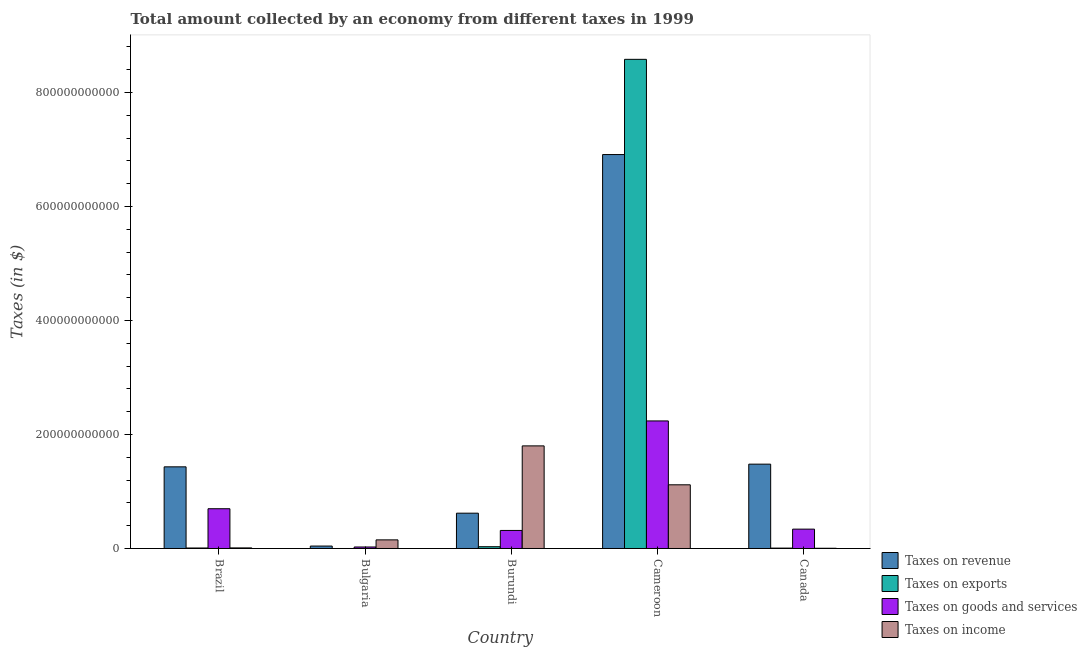How many groups of bars are there?
Your answer should be compact. 5. Are the number of bars on each tick of the X-axis equal?
Keep it short and to the point. No. How many bars are there on the 1st tick from the left?
Offer a very short reply. 4. How many bars are there on the 5th tick from the right?
Provide a short and direct response. 4. What is the label of the 5th group of bars from the left?
Ensure brevity in your answer.  Canada. In how many cases, is the number of bars for a given country not equal to the number of legend labels?
Keep it short and to the point. 1. What is the amount collected as tax on exports in Bulgaria?
Ensure brevity in your answer.  0. Across all countries, what is the maximum amount collected as tax on revenue?
Make the answer very short. 6.91e+11. Across all countries, what is the minimum amount collected as tax on goods?
Offer a terse response. 2.63e+09. In which country was the amount collected as tax on income maximum?
Give a very brief answer. Burundi. What is the total amount collected as tax on revenue in the graph?
Give a very brief answer. 1.05e+12. What is the difference between the amount collected as tax on income in Brazil and that in Burundi?
Keep it short and to the point. -1.79e+11. What is the difference between the amount collected as tax on exports in Bulgaria and the amount collected as tax on goods in Cameroon?
Offer a terse response. -2.24e+11. What is the average amount collected as tax on revenue per country?
Offer a very short reply. 2.10e+11. What is the difference between the amount collected as tax on revenue and amount collected as tax on exports in Cameroon?
Offer a very short reply. -1.67e+11. What is the ratio of the amount collected as tax on goods in Burundi to that in Cameroon?
Provide a succinct answer. 0.14. Is the amount collected as tax on exports in Burundi less than that in Canada?
Provide a succinct answer. No. Is the difference between the amount collected as tax on revenue in Brazil and Burundi greater than the difference between the amount collected as tax on exports in Brazil and Burundi?
Offer a very short reply. Yes. What is the difference between the highest and the second highest amount collected as tax on exports?
Provide a succinct answer. 8.55e+11. What is the difference between the highest and the lowest amount collected as tax on revenue?
Keep it short and to the point. 6.87e+11. Is it the case that in every country, the sum of the amount collected as tax on goods and amount collected as tax on revenue is greater than the sum of amount collected as tax on exports and amount collected as tax on income?
Offer a terse response. Yes. How many bars are there?
Make the answer very short. 19. Are all the bars in the graph horizontal?
Offer a very short reply. No. What is the difference between two consecutive major ticks on the Y-axis?
Offer a terse response. 2.00e+11. Does the graph contain grids?
Offer a very short reply. No. Where does the legend appear in the graph?
Your answer should be very brief. Bottom right. How many legend labels are there?
Ensure brevity in your answer.  4. How are the legend labels stacked?
Give a very brief answer. Vertical. What is the title of the graph?
Give a very brief answer. Total amount collected by an economy from different taxes in 1999. What is the label or title of the Y-axis?
Offer a very short reply. Taxes (in $). What is the Taxes (in $) of Taxes on revenue in Brazil?
Your response must be concise. 1.43e+11. What is the Taxes (in $) in Taxes on exports in Brazil?
Ensure brevity in your answer.  8.80e+08. What is the Taxes (in $) of Taxes on goods and services in Brazil?
Give a very brief answer. 6.97e+1. What is the Taxes (in $) of Taxes on income in Brazil?
Make the answer very short. 1.03e+09. What is the Taxes (in $) in Taxes on revenue in Bulgaria?
Your answer should be compact. 4.26e+09. What is the Taxes (in $) of Taxes on goods and services in Bulgaria?
Provide a succinct answer. 2.63e+09. What is the Taxes (in $) in Taxes on income in Bulgaria?
Provide a short and direct response. 1.51e+1. What is the Taxes (in $) in Taxes on revenue in Burundi?
Provide a short and direct response. 6.19e+1. What is the Taxes (in $) of Taxes on exports in Burundi?
Offer a terse response. 3.12e+09. What is the Taxes (in $) in Taxes on goods and services in Burundi?
Your answer should be very brief. 3.16e+1. What is the Taxes (in $) of Taxes on income in Burundi?
Keep it short and to the point. 1.80e+11. What is the Taxes (in $) in Taxes on revenue in Cameroon?
Ensure brevity in your answer.  6.91e+11. What is the Taxes (in $) in Taxes on exports in Cameroon?
Make the answer very short. 8.58e+11. What is the Taxes (in $) of Taxes on goods and services in Cameroon?
Provide a short and direct response. 2.24e+11. What is the Taxes (in $) of Taxes on income in Cameroon?
Ensure brevity in your answer.  1.12e+11. What is the Taxes (in $) in Taxes on revenue in Canada?
Your answer should be compact. 1.48e+11. What is the Taxes (in $) of Taxes on exports in Canada?
Keep it short and to the point. 6.70e+08. What is the Taxes (in $) in Taxes on goods and services in Canada?
Your response must be concise. 3.39e+1. What is the Taxes (in $) of Taxes on income in Canada?
Offer a very short reply. 4.08e+08. Across all countries, what is the maximum Taxes (in $) in Taxes on revenue?
Keep it short and to the point. 6.91e+11. Across all countries, what is the maximum Taxes (in $) of Taxes on exports?
Your response must be concise. 8.58e+11. Across all countries, what is the maximum Taxes (in $) of Taxes on goods and services?
Offer a terse response. 2.24e+11. Across all countries, what is the maximum Taxes (in $) in Taxes on income?
Provide a short and direct response. 1.80e+11. Across all countries, what is the minimum Taxes (in $) of Taxes on revenue?
Your response must be concise. 4.26e+09. Across all countries, what is the minimum Taxes (in $) of Taxes on goods and services?
Provide a succinct answer. 2.63e+09. Across all countries, what is the minimum Taxes (in $) in Taxes on income?
Your answer should be compact. 4.08e+08. What is the total Taxes (in $) in Taxes on revenue in the graph?
Your answer should be compact. 1.05e+12. What is the total Taxes (in $) of Taxes on exports in the graph?
Provide a short and direct response. 8.63e+11. What is the total Taxes (in $) of Taxes on goods and services in the graph?
Your response must be concise. 3.62e+11. What is the total Taxes (in $) in Taxes on income in the graph?
Provide a succinct answer. 3.08e+11. What is the difference between the Taxes (in $) of Taxes on revenue in Brazil and that in Bulgaria?
Your answer should be very brief. 1.39e+11. What is the difference between the Taxes (in $) in Taxes on goods and services in Brazil and that in Bulgaria?
Provide a short and direct response. 6.71e+1. What is the difference between the Taxes (in $) of Taxes on income in Brazil and that in Bulgaria?
Offer a very short reply. -1.41e+1. What is the difference between the Taxes (in $) in Taxes on revenue in Brazil and that in Burundi?
Provide a succinct answer. 8.13e+1. What is the difference between the Taxes (in $) of Taxes on exports in Brazil and that in Burundi?
Your answer should be compact. -2.24e+09. What is the difference between the Taxes (in $) in Taxes on goods and services in Brazil and that in Burundi?
Ensure brevity in your answer.  3.81e+1. What is the difference between the Taxes (in $) of Taxes on income in Brazil and that in Burundi?
Offer a terse response. -1.79e+11. What is the difference between the Taxes (in $) of Taxes on revenue in Brazil and that in Cameroon?
Provide a succinct answer. -5.48e+11. What is the difference between the Taxes (in $) in Taxes on exports in Brazil and that in Cameroon?
Your response must be concise. -8.57e+11. What is the difference between the Taxes (in $) in Taxes on goods and services in Brazil and that in Cameroon?
Your answer should be very brief. -1.54e+11. What is the difference between the Taxes (in $) in Taxes on income in Brazil and that in Cameroon?
Provide a succinct answer. -1.11e+11. What is the difference between the Taxes (in $) of Taxes on revenue in Brazil and that in Canada?
Ensure brevity in your answer.  -4.71e+09. What is the difference between the Taxes (in $) in Taxes on exports in Brazil and that in Canada?
Provide a succinct answer. 2.10e+08. What is the difference between the Taxes (in $) of Taxes on goods and services in Brazil and that in Canada?
Keep it short and to the point. 3.58e+1. What is the difference between the Taxes (in $) in Taxes on income in Brazil and that in Canada?
Make the answer very short. 6.21e+08. What is the difference between the Taxes (in $) in Taxes on revenue in Bulgaria and that in Burundi?
Give a very brief answer. -5.77e+1. What is the difference between the Taxes (in $) of Taxes on goods and services in Bulgaria and that in Burundi?
Offer a terse response. -2.90e+1. What is the difference between the Taxes (in $) in Taxes on income in Bulgaria and that in Burundi?
Offer a terse response. -1.65e+11. What is the difference between the Taxes (in $) of Taxes on revenue in Bulgaria and that in Cameroon?
Make the answer very short. -6.87e+11. What is the difference between the Taxes (in $) in Taxes on goods and services in Bulgaria and that in Cameroon?
Your answer should be compact. -2.21e+11. What is the difference between the Taxes (in $) in Taxes on income in Bulgaria and that in Cameroon?
Provide a short and direct response. -9.66e+1. What is the difference between the Taxes (in $) in Taxes on revenue in Bulgaria and that in Canada?
Your answer should be very brief. -1.44e+11. What is the difference between the Taxes (in $) in Taxes on goods and services in Bulgaria and that in Canada?
Offer a terse response. -3.13e+1. What is the difference between the Taxes (in $) in Taxes on income in Bulgaria and that in Canada?
Make the answer very short. 1.47e+1. What is the difference between the Taxes (in $) in Taxes on revenue in Burundi and that in Cameroon?
Ensure brevity in your answer.  -6.29e+11. What is the difference between the Taxes (in $) of Taxes on exports in Burundi and that in Cameroon?
Your answer should be compact. -8.55e+11. What is the difference between the Taxes (in $) in Taxes on goods and services in Burundi and that in Cameroon?
Keep it short and to the point. -1.92e+11. What is the difference between the Taxes (in $) of Taxes on income in Burundi and that in Cameroon?
Offer a terse response. 6.83e+1. What is the difference between the Taxes (in $) in Taxes on revenue in Burundi and that in Canada?
Give a very brief answer. -8.60e+1. What is the difference between the Taxes (in $) of Taxes on exports in Burundi and that in Canada?
Provide a succinct answer. 2.45e+09. What is the difference between the Taxes (in $) in Taxes on goods and services in Burundi and that in Canada?
Give a very brief answer. -2.31e+09. What is the difference between the Taxes (in $) in Taxes on income in Burundi and that in Canada?
Give a very brief answer. 1.80e+11. What is the difference between the Taxes (in $) in Taxes on revenue in Cameroon and that in Canada?
Your answer should be very brief. 5.43e+11. What is the difference between the Taxes (in $) of Taxes on exports in Cameroon and that in Canada?
Make the answer very short. 8.57e+11. What is the difference between the Taxes (in $) in Taxes on goods and services in Cameroon and that in Canada?
Your response must be concise. 1.90e+11. What is the difference between the Taxes (in $) in Taxes on income in Cameroon and that in Canada?
Keep it short and to the point. 1.11e+11. What is the difference between the Taxes (in $) in Taxes on revenue in Brazil and the Taxes (in $) in Taxes on goods and services in Bulgaria?
Keep it short and to the point. 1.41e+11. What is the difference between the Taxes (in $) of Taxes on revenue in Brazil and the Taxes (in $) of Taxes on income in Bulgaria?
Give a very brief answer. 1.28e+11. What is the difference between the Taxes (in $) in Taxes on exports in Brazil and the Taxes (in $) in Taxes on goods and services in Bulgaria?
Your response must be concise. -1.75e+09. What is the difference between the Taxes (in $) of Taxes on exports in Brazil and the Taxes (in $) of Taxes on income in Bulgaria?
Make the answer very short. -1.42e+1. What is the difference between the Taxes (in $) in Taxes on goods and services in Brazil and the Taxes (in $) in Taxes on income in Bulgaria?
Your response must be concise. 5.46e+1. What is the difference between the Taxes (in $) in Taxes on revenue in Brazil and the Taxes (in $) in Taxes on exports in Burundi?
Your answer should be very brief. 1.40e+11. What is the difference between the Taxes (in $) in Taxes on revenue in Brazil and the Taxes (in $) in Taxes on goods and services in Burundi?
Give a very brief answer. 1.12e+11. What is the difference between the Taxes (in $) of Taxes on revenue in Brazil and the Taxes (in $) of Taxes on income in Burundi?
Your answer should be compact. -3.68e+1. What is the difference between the Taxes (in $) in Taxes on exports in Brazil and the Taxes (in $) in Taxes on goods and services in Burundi?
Ensure brevity in your answer.  -3.08e+1. What is the difference between the Taxes (in $) of Taxes on exports in Brazil and the Taxes (in $) of Taxes on income in Burundi?
Provide a short and direct response. -1.79e+11. What is the difference between the Taxes (in $) in Taxes on goods and services in Brazil and the Taxes (in $) in Taxes on income in Burundi?
Make the answer very short. -1.10e+11. What is the difference between the Taxes (in $) of Taxes on revenue in Brazil and the Taxes (in $) of Taxes on exports in Cameroon?
Provide a succinct answer. -7.15e+11. What is the difference between the Taxes (in $) in Taxes on revenue in Brazil and the Taxes (in $) in Taxes on goods and services in Cameroon?
Your response must be concise. -8.05e+1. What is the difference between the Taxes (in $) of Taxes on revenue in Brazil and the Taxes (in $) of Taxes on income in Cameroon?
Your response must be concise. 3.15e+1. What is the difference between the Taxes (in $) in Taxes on exports in Brazil and the Taxes (in $) in Taxes on goods and services in Cameroon?
Your response must be concise. -2.23e+11. What is the difference between the Taxes (in $) in Taxes on exports in Brazil and the Taxes (in $) in Taxes on income in Cameroon?
Your answer should be compact. -1.11e+11. What is the difference between the Taxes (in $) of Taxes on goods and services in Brazil and the Taxes (in $) of Taxes on income in Cameroon?
Keep it short and to the point. -4.20e+1. What is the difference between the Taxes (in $) of Taxes on revenue in Brazil and the Taxes (in $) of Taxes on exports in Canada?
Provide a succinct answer. 1.43e+11. What is the difference between the Taxes (in $) in Taxes on revenue in Brazil and the Taxes (in $) in Taxes on goods and services in Canada?
Provide a short and direct response. 1.09e+11. What is the difference between the Taxes (in $) of Taxes on revenue in Brazil and the Taxes (in $) of Taxes on income in Canada?
Offer a very short reply. 1.43e+11. What is the difference between the Taxes (in $) of Taxes on exports in Brazil and the Taxes (in $) of Taxes on goods and services in Canada?
Make the answer very short. -3.31e+1. What is the difference between the Taxes (in $) of Taxes on exports in Brazil and the Taxes (in $) of Taxes on income in Canada?
Keep it short and to the point. 4.72e+08. What is the difference between the Taxes (in $) of Taxes on goods and services in Brazil and the Taxes (in $) of Taxes on income in Canada?
Your response must be concise. 6.93e+1. What is the difference between the Taxes (in $) of Taxes on revenue in Bulgaria and the Taxes (in $) of Taxes on exports in Burundi?
Give a very brief answer. 1.14e+09. What is the difference between the Taxes (in $) in Taxes on revenue in Bulgaria and the Taxes (in $) in Taxes on goods and services in Burundi?
Make the answer very short. -2.74e+1. What is the difference between the Taxes (in $) in Taxes on revenue in Bulgaria and the Taxes (in $) in Taxes on income in Burundi?
Your answer should be compact. -1.76e+11. What is the difference between the Taxes (in $) in Taxes on goods and services in Bulgaria and the Taxes (in $) in Taxes on income in Burundi?
Your answer should be compact. -1.77e+11. What is the difference between the Taxes (in $) of Taxes on revenue in Bulgaria and the Taxes (in $) of Taxes on exports in Cameroon?
Keep it short and to the point. -8.54e+11. What is the difference between the Taxes (in $) of Taxes on revenue in Bulgaria and the Taxes (in $) of Taxes on goods and services in Cameroon?
Keep it short and to the point. -2.19e+11. What is the difference between the Taxes (in $) of Taxes on revenue in Bulgaria and the Taxes (in $) of Taxes on income in Cameroon?
Keep it short and to the point. -1.07e+11. What is the difference between the Taxes (in $) of Taxes on goods and services in Bulgaria and the Taxes (in $) of Taxes on income in Cameroon?
Your answer should be very brief. -1.09e+11. What is the difference between the Taxes (in $) of Taxes on revenue in Bulgaria and the Taxes (in $) of Taxes on exports in Canada?
Give a very brief answer. 3.59e+09. What is the difference between the Taxes (in $) in Taxes on revenue in Bulgaria and the Taxes (in $) in Taxes on goods and services in Canada?
Make the answer very short. -2.97e+1. What is the difference between the Taxes (in $) in Taxes on revenue in Bulgaria and the Taxes (in $) in Taxes on income in Canada?
Ensure brevity in your answer.  3.85e+09. What is the difference between the Taxes (in $) in Taxes on goods and services in Bulgaria and the Taxes (in $) in Taxes on income in Canada?
Ensure brevity in your answer.  2.23e+09. What is the difference between the Taxes (in $) in Taxes on revenue in Burundi and the Taxes (in $) in Taxes on exports in Cameroon?
Offer a very short reply. -7.96e+11. What is the difference between the Taxes (in $) in Taxes on revenue in Burundi and the Taxes (in $) in Taxes on goods and services in Cameroon?
Give a very brief answer. -1.62e+11. What is the difference between the Taxes (in $) of Taxes on revenue in Burundi and the Taxes (in $) of Taxes on income in Cameroon?
Keep it short and to the point. -4.98e+1. What is the difference between the Taxes (in $) in Taxes on exports in Burundi and the Taxes (in $) in Taxes on goods and services in Cameroon?
Ensure brevity in your answer.  -2.21e+11. What is the difference between the Taxes (in $) in Taxes on exports in Burundi and the Taxes (in $) in Taxes on income in Cameroon?
Provide a short and direct response. -1.09e+11. What is the difference between the Taxes (in $) in Taxes on goods and services in Burundi and the Taxes (in $) in Taxes on income in Cameroon?
Provide a succinct answer. -8.01e+1. What is the difference between the Taxes (in $) of Taxes on revenue in Burundi and the Taxes (in $) of Taxes on exports in Canada?
Provide a succinct answer. 6.13e+1. What is the difference between the Taxes (in $) of Taxes on revenue in Burundi and the Taxes (in $) of Taxes on goods and services in Canada?
Your response must be concise. 2.80e+1. What is the difference between the Taxes (in $) in Taxes on revenue in Burundi and the Taxes (in $) in Taxes on income in Canada?
Your response must be concise. 6.15e+1. What is the difference between the Taxes (in $) of Taxes on exports in Burundi and the Taxes (in $) of Taxes on goods and services in Canada?
Provide a succinct answer. -3.08e+1. What is the difference between the Taxes (in $) of Taxes on exports in Burundi and the Taxes (in $) of Taxes on income in Canada?
Your answer should be compact. 2.71e+09. What is the difference between the Taxes (in $) in Taxes on goods and services in Burundi and the Taxes (in $) in Taxes on income in Canada?
Provide a succinct answer. 3.12e+1. What is the difference between the Taxes (in $) of Taxes on revenue in Cameroon and the Taxes (in $) of Taxes on exports in Canada?
Offer a terse response. 6.90e+11. What is the difference between the Taxes (in $) of Taxes on revenue in Cameroon and the Taxes (in $) of Taxes on goods and services in Canada?
Give a very brief answer. 6.57e+11. What is the difference between the Taxes (in $) of Taxes on revenue in Cameroon and the Taxes (in $) of Taxes on income in Canada?
Keep it short and to the point. 6.91e+11. What is the difference between the Taxes (in $) of Taxes on exports in Cameroon and the Taxes (in $) of Taxes on goods and services in Canada?
Provide a short and direct response. 8.24e+11. What is the difference between the Taxes (in $) in Taxes on exports in Cameroon and the Taxes (in $) in Taxes on income in Canada?
Your answer should be very brief. 8.58e+11. What is the difference between the Taxes (in $) of Taxes on goods and services in Cameroon and the Taxes (in $) of Taxes on income in Canada?
Offer a very short reply. 2.23e+11. What is the average Taxes (in $) of Taxes on revenue per country?
Provide a short and direct response. 2.10e+11. What is the average Taxes (in $) in Taxes on exports per country?
Your response must be concise. 1.73e+11. What is the average Taxes (in $) of Taxes on goods and services per country?
Offer a terse response. 7.23e+1. What is the average Taxes (in $) of Taxes on income per country?
Your answer should be very brief. 6.16e+1. What is the difference between the Taxes (in $) in Taxes on revenue and Taxes (in $) in Taxes on exports in Brazil?
Provide a succinct answer. 1.42e+11. What is the difference between the Taxes (in $) in Taxes on revenue and Taxes (in $) in Taxes on goods and services in Brazil?
Your response must be concise. 7.35e+1. What is the difference between the Taxes (in $) in Taxes on revenue and Taxes (in $) in Taxes on income in Brazil?
Offer a very short reply. 1.42e+11. What is the difference between the Taxes (in $) of Taxes on exports and Taxes (in $) of Taxes on goods and services in Brazil?
Offer a very short reply. -6.89e+1. What is the difference between the Taxes (in $) in Taxes on exports and Taxes (in $) in Taxes on income in Brazil?
Ensure brevity in your answer.  -1.49e+08. What is the difference between the Taxes (in $) in Taxes on goods and services and Taxes (in $) in Taxes on income in Brazil?
Give a very brief answer. 6.87e+1. What is the difference between the Taxes (in $) of Taxes on revenue and Taxes (in $) of Taxes on goods and services in Bulgaria?
Provide a short and direct response. 1.63e+09. What is the difference between the Taxes (in $) of Taxes on revenue and Taxes (in $) of Taxes on income in Bulgaria?
Offer a terse response. -1.09e+1. What is the difference between the Taxes (in $) of Taxes on goods and services and Taxes (in $) of Taxes on income in Bulgaria?
Offer a terse response. -1.25e+1. What is the difference between the Taxes (in $) of Taxes on revenue and Taxes (in $) of Taxes on exports in Burundi?
Give a very brief answer. 5.88e+1. What is the difference between the Taxes (in $) in Taxes on revenue and Taxes (in $) in Taxes on goods and services in Burundi?
Offer a very short reply. 3.03e+1. What is the difference between the Taxes (in $) in Taxes on revenue and Taxes (in $) in Taxes on income in Burundi?
Give a very brief answer. -1.18e+11. What is the difference between the Taxes (in $) in Taxes on exports and Taxes (in $) in Taxes on goods and services in Burundi?
Keep it short and to the point. -2.85e+1. What is the difference between the Taxes (in $) of Taxes on exports and Taxes (in $) of Taxes on income in Burundi?
Your answer should be very brief. -1.77e+11. What is the difference between the Taxes (in $) in Taxes on goods and services and Taxes (in $) in Taxes on income in Burundi?
Offer a very short reply. -1.48e+11. What is the difference between the Taxes (in $) in Taxes on revenue and Taxes (in $) in Taxes on exports in Cameroon?
Your answer should be compact. -1.67e+11. What is the difference between the Taxes (in $) of Taxes on revenue and Taxes (in $) of Taxes on goods and services in Cameroon?
Offer a terse response. 4.67e+11. What is the difference between the Taxes (in $) in Taxes on revenue and Taxes (in $) in Taxes on income in Cameroon?
Give a very brief answer. 5.79e+11. What is the difference between the Taxes (in $) of Taxes on exports and Taxes (in $) of Taxes on goods and services in Cameroon?
Offer a very short reply. 6.34e+11. What is the difference between the Taxes (in $) of Taxes on exports and Taxes (in $) of Taxes on income in Cameroon?
Make the answer very short. 7.46e+11. What is the difference between the Taxes (in $) of Taxes on goods and services and Taxes (in $) of Taxes on income in Cameroon?
Your response must be concise. 1.12e+11. What is the difference between the Taxes (in $) in Taxes on revenue and Taxes (in $) in Taxes on exports in Canada?
Give a very brief answer. 1.47e+11. What is the difference between the Taxes (in $) of Taxes on revenue and Taxes (in $) of Taxes on goods and services in Canada?
Keep it short and to the point. 1.14e+11. What is the difference between the Taxes (in $) of Taxes on revenue and Taxes (in $) of Taxes on income in Canada?
Offer a terse response. 1.48e+11. What is the difference between the Taxes (in $) of Taxes on exports and Taxes (in $) of Taxes on goods and services in Canada?
Offer a terse response. -3.33e+1. What is the difference between the Taxes (in $) in Taxes on exports and Taxes (in $) in Taxes on income in Canada?
Offer a terse response. 2.62e+08. What is the difference between the Taxes (in $) in Taxes on goods and services and Taxes (in $) in Taxes on income in Canada?
Offer a very short reply. 3.35e+1. What is the ratio of the Taxes (in $) in Taxes on revenue in Brazil to that in Bulgaria?
Ensure brevity in your answer.  33.62. What is the ratio of the Taxes (in $) in Taxes on goods and services in Brazil to that in Bulgaria?
Your answer should be compact. 26.48. What is the ratio of the Taxes (in $) in Taxes on income in Brazil to that in Bulgaria?
Your answer should be compact. 0.07. What is the ratio of the Taxes (in $) in Taxes on revenue in Brazil to that in Burundi?
Your answer should be very brief. 2.31. What is the ratio of the Taxes (in $) of Taxes on exports in Brazil to that in Burundi?
Offer a very short reply. 0.28. What is the ratio of the Taxes (in $) of Taxes on goods and services in Brazil to that in Burundi?
Keep it short and to the point. 2.2. What is the ratio of the Taxes (in $) in Taxes on income in Brazil to that in Burundi?
Your response must be concise. 0.01. What is the ratio of the Taxes (in $) in Taxes on revenue in Brazil to that in Cameroon?
Offer a very short reply. 0.21. What is the ratio of the Taxes (in $) in Taxes on goods and services in Brazil to that in Cameroon?
Make the answer very short. 0.31. What is the ratio of the Taxes (in $) in Taxes on income in Brazil to that in Cameroon?
Provide a short and direct response. 0.01. What is the ratio of the Taxes (in $) of Taxes on revenue in Brazil to that in Canada?
Your answer should be very brief. 0.97. What is the ratio of the Taxes (in $) of Taxes on exports in Brazil to that in Canada?
Your answer should be compact. 1.31. What is the ratio of the Taxes (in $) in Taxes on goods and services in Brazil to that in Canada?
Your answer should be compact. 2.05. What is the ratio of the Taxes (in $) of Taxes on income in Brazil to that in Canada?
Offer a terse response. 2.52. What is the ratio of the Taxes (in $) of Taxes on revenue in Bulgaria to that in Burundi?
Make the answer very short. 0.07. What is the ratio of the Taxes (in $) of Taxes on goods and services in Bulgaria to that in Burundi?
Offer a terse response. 0.08. What is the ratio of the Taxes (in $) in Taxes on income in Bulgaria to that in Burundi?
Your answer should be compact. 0.08. What is the ratio of the Taxes (in $) of Taxes on revenue in Bulgaria to that in Cameroon?
Provide a succinct answer. 0.01. What is the ratio of the Taxes (in $) in Taxes on goods and services in Bulgaria to that in Cameroon?
Provide a succinct answer. 0.01. What is the ratio of the Taxes (in $) of Taxes on income in Bulgaria to that in Cameroon?
Give a very brief answer. 0.14. What is the ratio of the Taxes (in $) in Taxes on revenue in Bulgaria to that in Canada?
Offer a very short reply. 0.03. What is the ratio of the Taxes (in $) of Taxes on goods and services in Bulgaria to that in Canada?
Make the answer very short. 0.08. What is the ratio of the Taxes (in $) in Taxes on income in Bulgaria to that in Canada?
Keep it short and to the point. 37.06. What is the ratio of the Taxes (in $) in Taxes on revenue in Burundi to that in Cameroon?
Offer a terse response. 0.09. What is the ratio of the Taxes (in $) of Taxes on exports in Burundi to that in Cameroon?
Offer a terse response. 0. What is the ratio of the Taxes (in $) in Taxes on goods and services in Burundi to that in Cameroon?
Your response must be concise. 0.14. What is the ratio of the Taxes (in $) of Taxes on income in Burundi to that in Cameroon?
Your answer should be very brief. 1.61. What is the ratio of the Taxes (in $) in Taxes on revenue in Burundi to that in Canada?
Your answer should be compact. 0.42. What is the ratio of the Taxes (in $) in Taxes on exports in Burundi to that in Canada?
Offer a terse response. 4.66. What is the ratio of the Taxes (in $) in Taxes on goods and services in Burundi to that in Canada?
Ensure brevity in your answer.  0.93. What is the ratio of the Taxes (in $) of Taxes on income in Burundi to that in Canada?
Your answer should be compact. 441.13. What is the ratio of the Taxes (in $) in Taxes on revenue in Cameroon to that in Canada?
Give a very brief answer. 4.67. What is the ratio of the Taxes (in $) of Taxes on exports in Cameroon to that in Canada?
Provide a short and direct response. 1280.6. What is the ratio of the Taxes (in $) of Taxes on goods and services in Cameroon to that in Canada?
Your response must be concise. 6.59. What is the ratio of the Taxes (in $) in Taxes on income in Cameroon to that in Canada?
Offer a terse response. 273.77. What is the difference between the highest and the second highest Taxes (in $) of Taxes on revenue?
Make the answer very short. 5.43e+11. What is the difference between the highest and the second highest Taxes (in $) in Taxes on exports?
Offer a terse response. 8.55e+11. What is the difference between the highest and the second highest Taxes (in $) in Taxes on goods and services?
Provide a short and direct response. 1.54e+11. What is the difference between the highest and the second highest Taxes (in $) of Taxes on income?
Your response must be concise. 6.83e+1. What is the difference between the highest and the lowest Taxes (in $) in Taxes on revenue?
Your answer should be compact. 6.87e+11. What is the difference between the highest and the lowest Taxes (in $) in Taxes on exports?
Make the answer very short. 8.58e+11. What is the difference between the highest and the lowest Taxes (in $) in Taxes on goods and services?
Give a very brief answer. 2.21e+11. What is the difference between the highest and the lowest Taxes (in $) in Taxes on income?
Make the answer very short. 1.80e+11. 